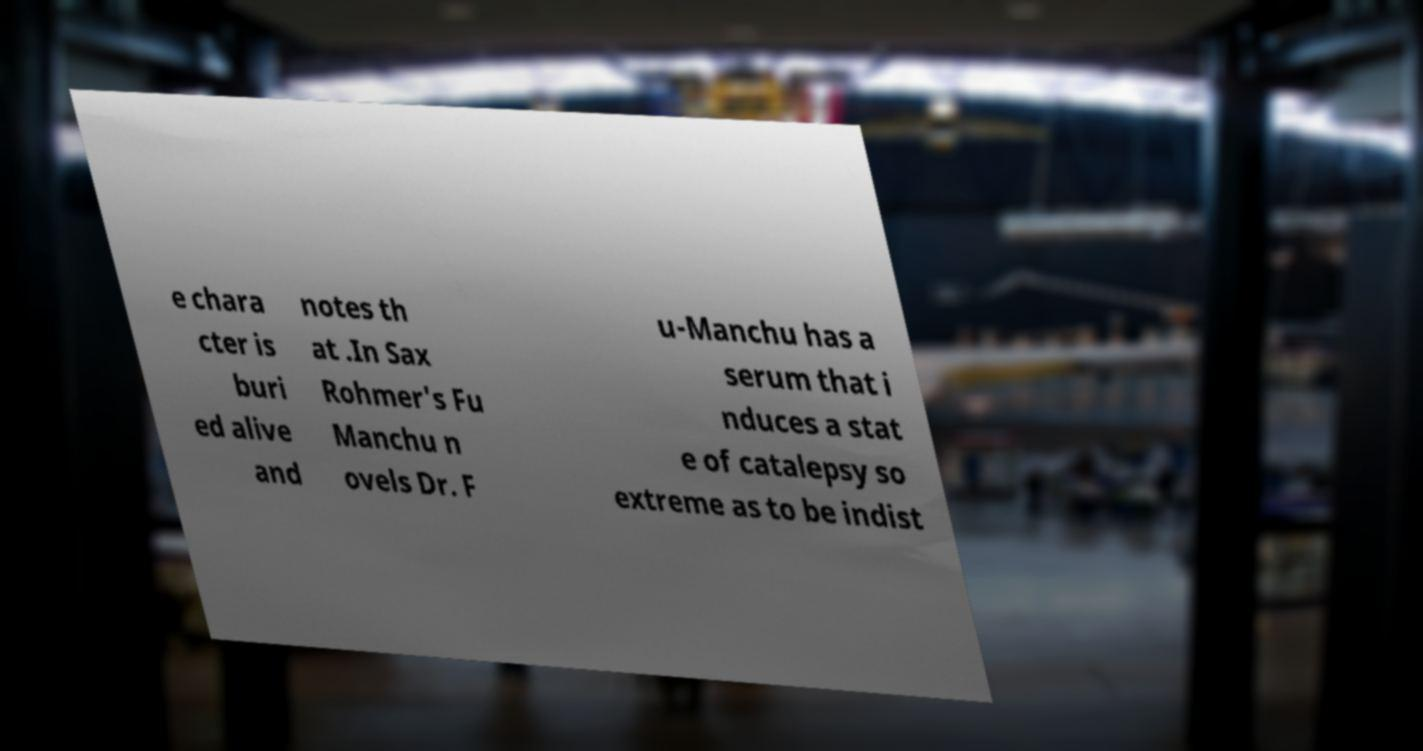What messages or text are displayed in this image? I need them in a readable, typed format. e chara cter is buri ed alive and notes th at .In Sax Rohmer's Fu Manchu n ovels Dr. F u-Manchu has a serum that i nduces a stat e of catalepsy so extreme as to be indist 